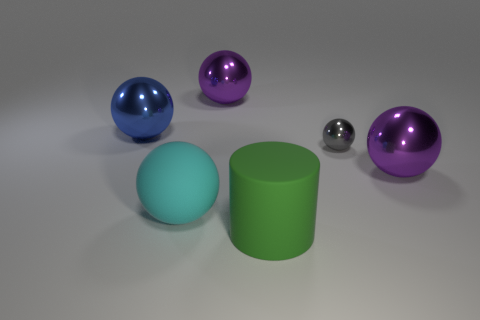Subtract 1 balls. How many balls are left? 4 Subtract all cyan balls. How many balls are left? 4 Subtract all blue balls. How many balls are left? 4 Subtract all brown spheres. Subtract all blue cubes. How many spheres are left? 5 Add 3 tiny gray spheres. How many objects exist? 9 Subtract all cylinders. How many objects are left? 5 Subtract all tiny red matte blocks. Subtract all cyan rubber balls. How many objects are left? 5 Add 2 large blue things. How many large blue things are left? 3 Add 1 large gray metal cylinders. How many large gray metal cylinders exist? 1 Subtract 1 cyan spheres. How many objects are left? 5 